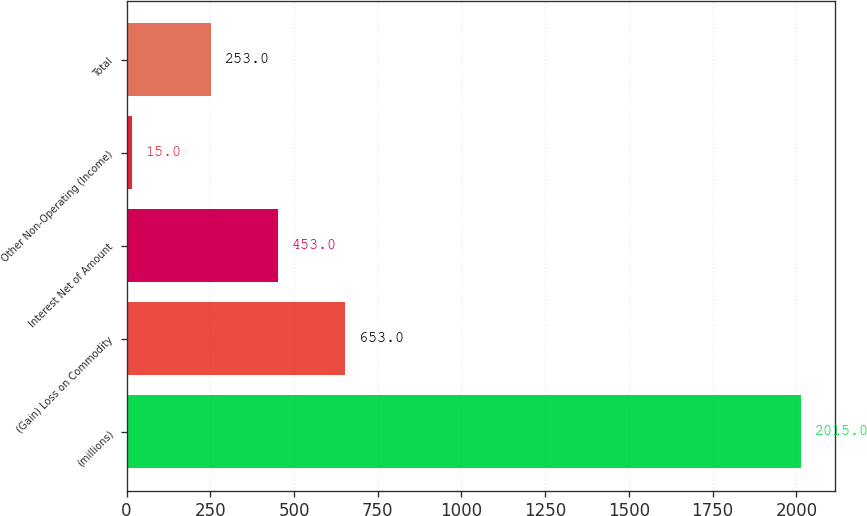Convert chart. <chart><loc_0><loc_0><loc_500><loc_500><bar_chart><fcel>(millions)<fcel>(Gain) Loss on Commodity<fcel>Interest Net of Amount<fcel>Other Non-Operating (Income)<fcel>Total<nl><fcel>2015<fcel>653<fcel>453<fcel>15<fcel>253<nl></chart> 